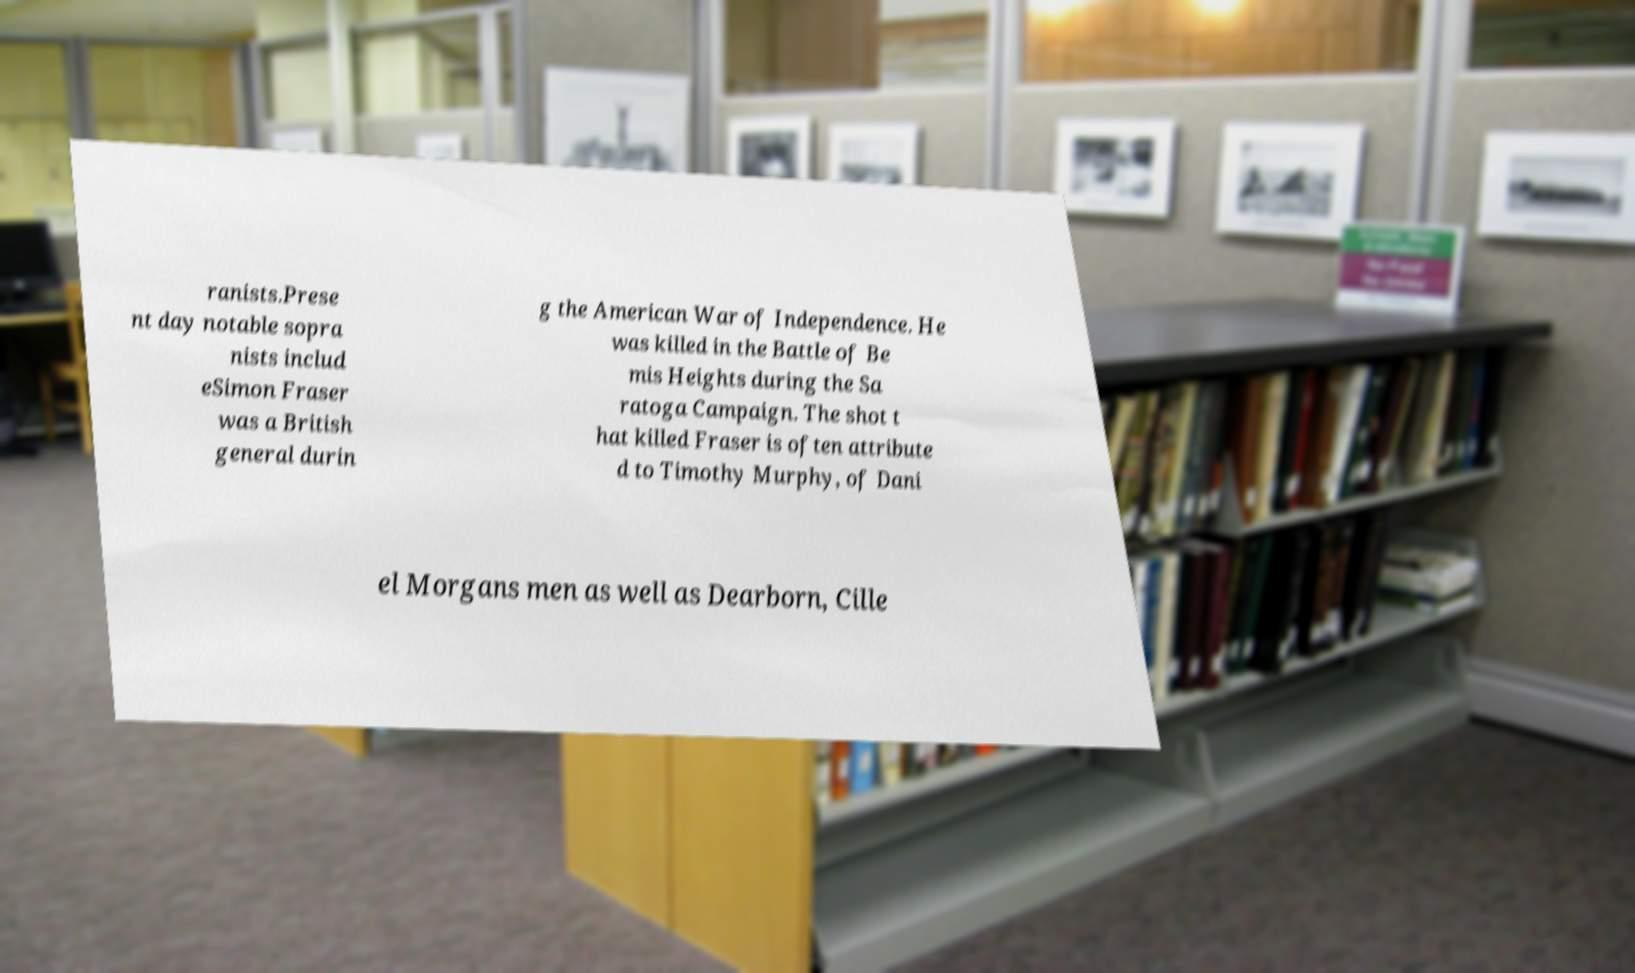There's text embedded in this image that I need extracted. Can you transcribe it verbatim? ranists.Prese nt day notable sopra nists includ eSimon Fraser was a British general durin g the American War of Independence. He was killed in the Battle of Be mis Heights during the Sa ratoga Campaign. The shot t hat killed Fraser is often attribute d to Timothy Murphy, of Dani el Morgans men as well as Dearborn, Cille 